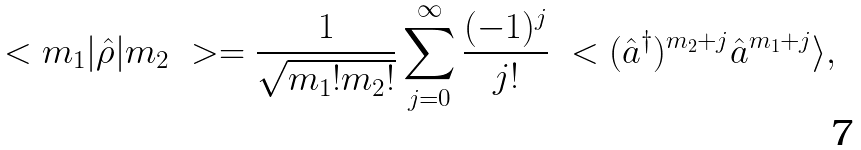<formula> <loc_0><loc_0><loc_500><loc_500>\ < m _ { 1 } | \hat { \rho } | m _ { 2 } \ > = { \frac { 1 } { \sqrt { m _ { 1 } ! m _ { 2 } ! } } } \sum _ { j = 0 } ^ { \infty } { \frac { ( - 1 ) ^ { j } } { j ! } } \ < ( \hat { a } ^ { \dag } ) ^ { m _ { 2 } + j } \hat { a } ^ { m _ { 1 } + j } \rangle ,</formula> 